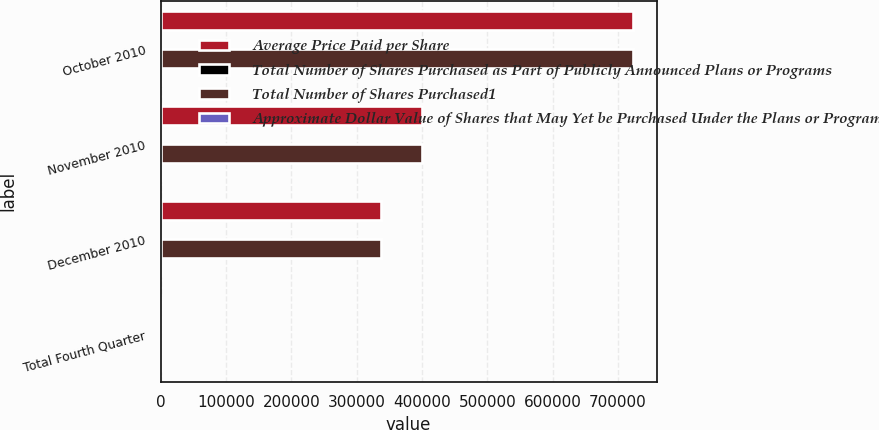Convert chart to OTSL. <chart><loc_0><loc_0><loc_500><loc_500><stacked_bar_chart><ecel><fcel>October 2010<fcel>November 2010<fcel>December 2010<fcel>Total Fourth Quarter<nl><fcel>Average Price Paid per Share<fcel>722890<fcel>400692<fcel>337100<fcel>358.7<nl><fcel>Total Number of Shares Purchased as Part of Publicly Announced Plans or Programs<fcel>50.76<fcel>51.81<fcel>50.89<fcel>51.08<nl><fcel>Total Number of Shares Purchased1<fcel>722890<fcel>400692<fcel>337100<fcel>358.7<nl><fcel>Approximate Dollar Value of Shares that May Yet be Purchased Under the Plans or Programs in millions<fcel>369.1<fcel>348.3<fcel>331.1<fcel>331.1<nl></chart> 